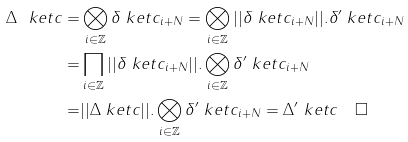Convert formula to latex. <formula><loc_0><loc_0><loc_500><loc_500>\Delta \ k e t { c } = & \bigotimes _ { i \in \mathbb { Z } } \delta \ k e t { c _ { i + N } } = \bigotimes _ { i \in \mathbb { Z } } | | \delta \ k e t { c _ { i + N } } | | . \delta ^ { \prime } \ k e t { c _ { i + N } } \\ = & \prod _ { i \in \mathbb { Z } } | | \delta \ k e t { c _ { i + N } } | | . \bigotimes _ { i \in \mathbb { Z } } \delta ^ { \prime } \ k e t { c _ { i + N } } \\ = & | | \Delta \ k e t { c } | | . \bigotimes _ { i \in \mathbb { Z } } \delta ^ { \prime } \ k e t { c _ { i + N } } = \Delta ^ { \prime } \ k e t { c } \quad \Box</formula> 